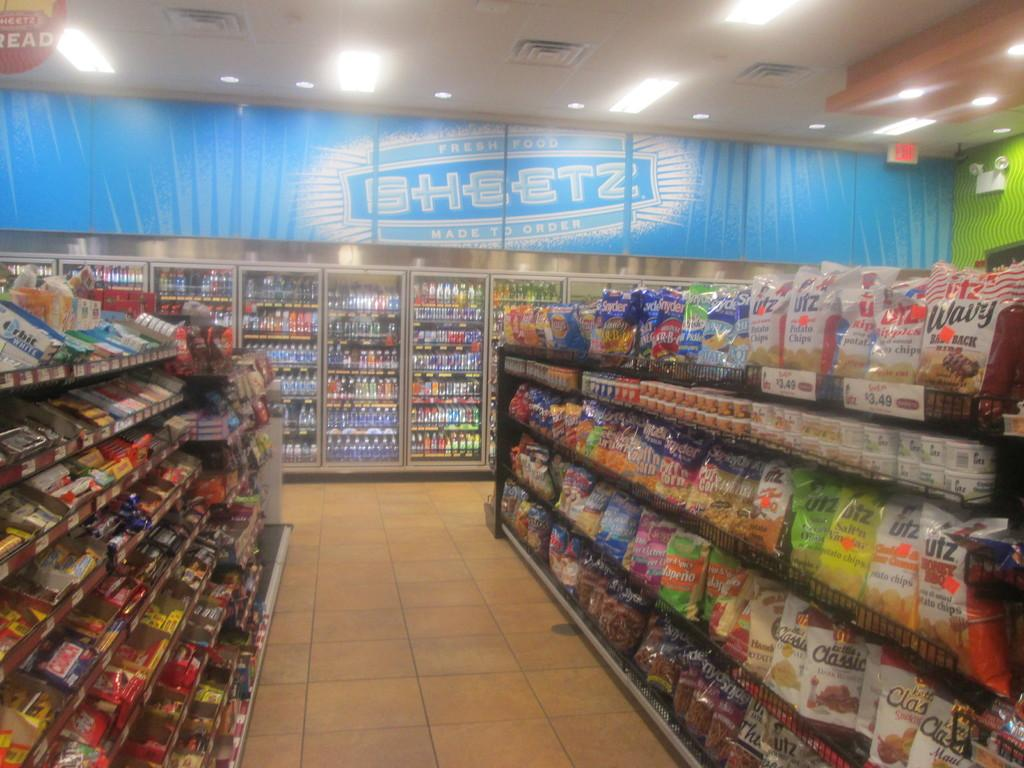<image>
Provide a brief description of the given image. A blue Sheetz banner is in the background of this convenience store. 